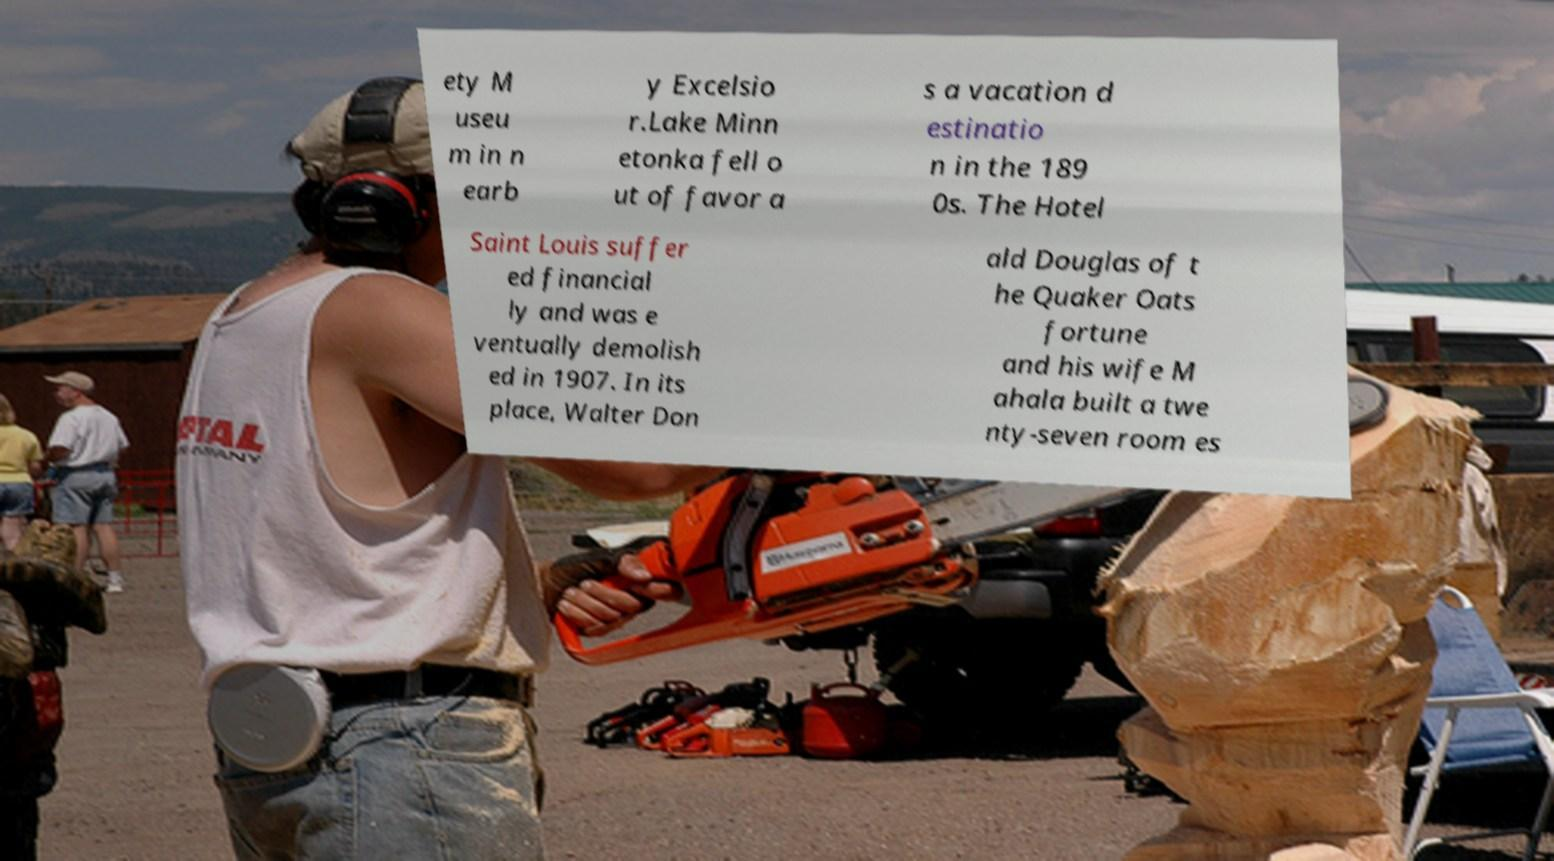Could you assist in decoding the text presented in this image and type it out clearly? ety M useu m in n earb y Excelsio r.Lake Minn etonka fell o ut of favor a s a vacation d estinatio n in the 189 0s. The Hotel Saint Louis suffer ed financial ly and was e ventually demolish ed in 1907. In its place, Walter Don ald Douglas of t he Quaker Oats fortune and his wife M ahala built a twe nty-seven room es 